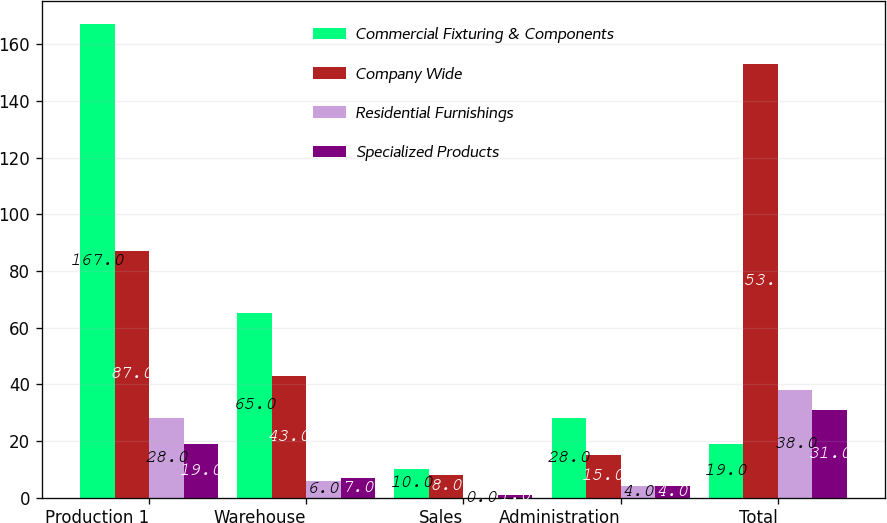Convert chart to OTSL. <chart><loc_0><loc_0><loc_500><loc_500><stacked_bar_chart><ecel><fcel>Production 1<fcel>Warehouse<fcel>Sales<fcel>Administration<fcel>Total<nl><fcel>Commercial Fixturing & Components<fcel>167<fcel>65<fcel>10<fcel>28<fcel>19<nl><fcel>Company Wide<fcel>87<fcel>43<fcel>8<fcel>15<fcel>153<nl><fcel>Residential Furnishings<fcel>28<fcel>6<fcel>0<fcel>4<fcel>38<nl><fcel>Specialized Products<fcel>19<fcel>7<fcel>1<fcel>4<fcel>31<nl></chart> 